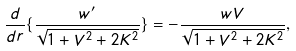Convert formula to latex. <formula><loc_0><loc_0><loc_500><loc_500>\frac { d } { d r } \{ \frac { w ^ { \prime } } { \sqrt { 1 + V ^ { 2 } + 2 K ^ { 2 } } } \} = - \frac { w V } { \sqrt { 1 + V ^ { 2 } + 2 K ^ { 2 } } } ,</formula> 